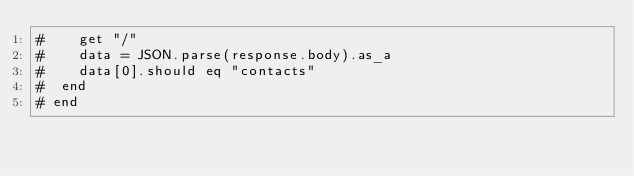Convert code to text. <code><loc_0><loc_0><loc_500><loc_500><_Crystal_>#    get "/"
#    data = JSON.parse(response.body).as_a
#    data[0].should eq "contacts"
#  end
# end
</code> 